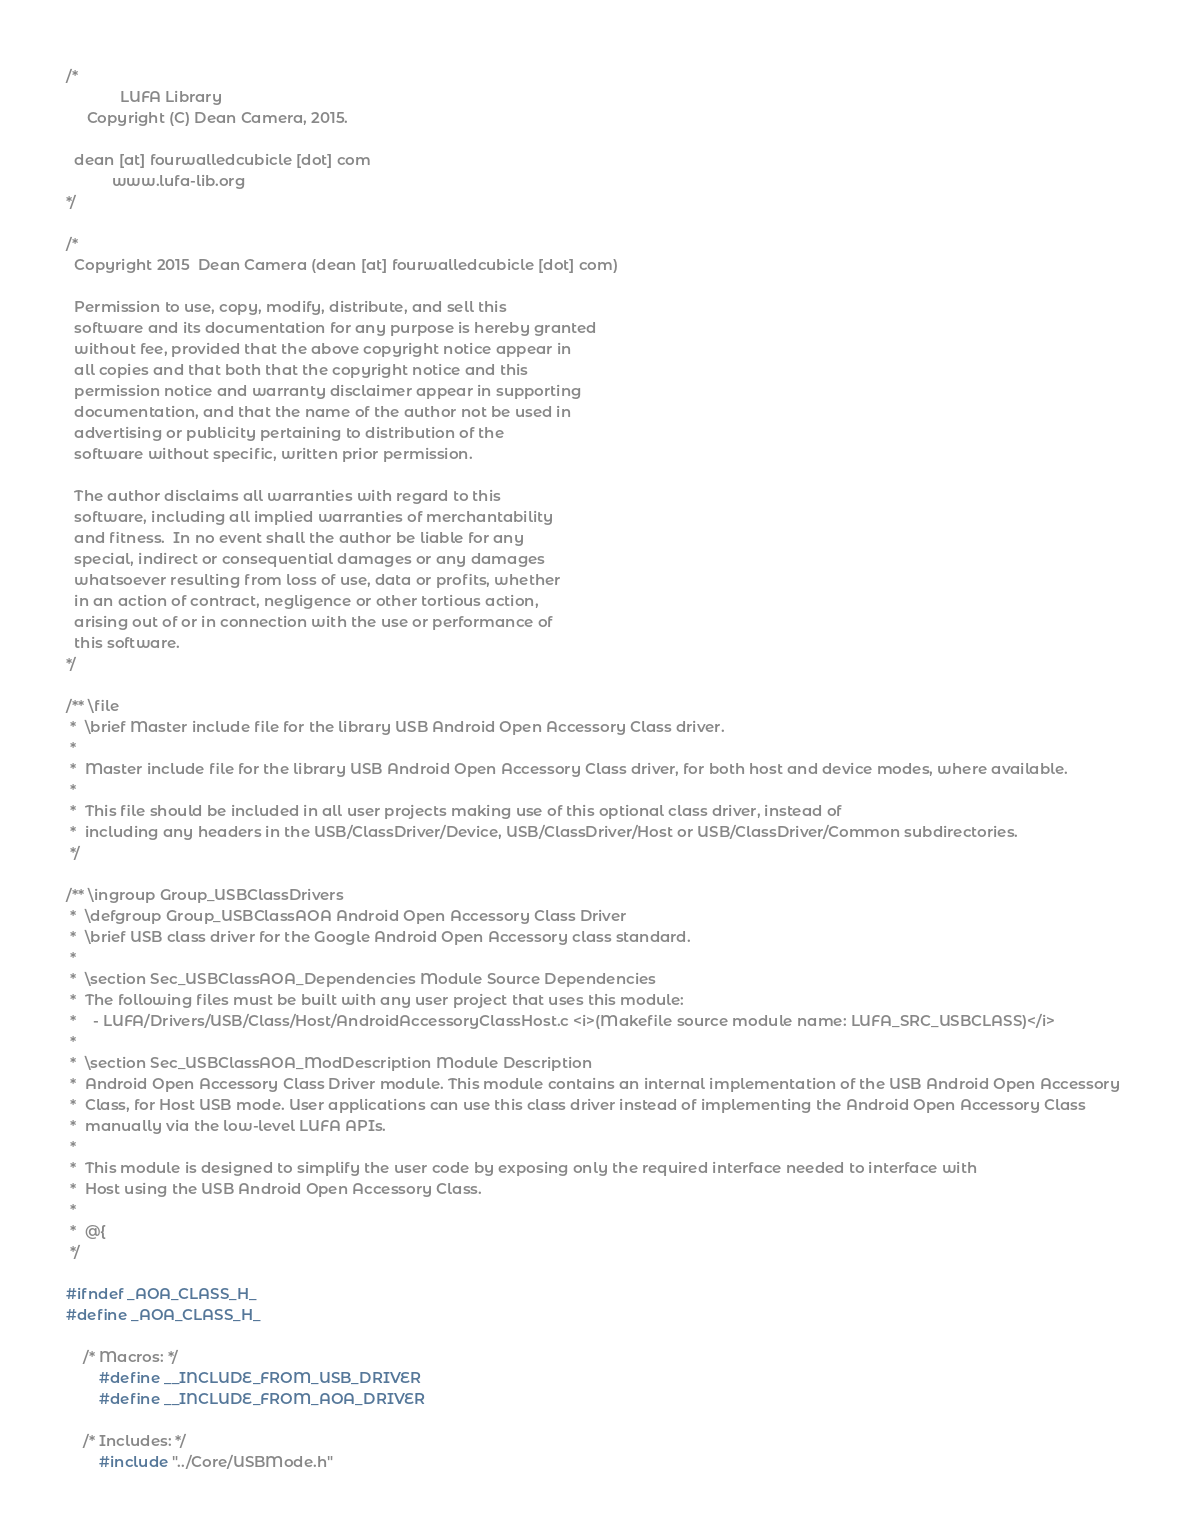<code> <loc_0><loc_0><loc_500><loc_500><_C_>/*
             LUFA Library
     Copyright (C) Dean Camera, 2015.

  dean [at] fourwalledcubicle [dot] com
           www.lufa-lib.org
*/

/*
  Copyright 2015  Dean Camera (dean [at] fourwalledcubicle [dot] com)

  Permission to use, copy, modify, distribute, and sell this
  software and its documentation for any purpose is hereby granted
  without fee, provided that the above copyright notice appear in
  all copies and that both that the copyright notice and this
  permission notice and warranty disclaimer appear in supporting
  documentation, and that the name of the author not be used in
  advertising or publicity pertaining to distribution of the
  software without specific, written prior permission.

  The author disclaims all warranties with regard to this
  software, including all implied warranties of merchantability
  and fitness.  In no event shall the author be liable for any
  special, indirect or consequential damages or any damages
  whatsoever resulting from loss of use, data or profits, whether
  in an action of contract, negligence or other tortious action,
  arising out of or in connection with the use or performance of
  this software.
*/

/** \file
 *  \brief Master include file for the library USB Android Open Accessory Class driver.
 *
 *  Master include file for the library USB Android Open Accessory Class driver, for both host and device modes, where available.
 *
 *  This file should be included in all user projects making use of this optional class driver, instead of
 *  including any headers in the USB/ClassDriver/Device, USB/ClassDriver/Host or USB/ClassDriver/Common subdirectories.
 */

/** \ingroup Group_USBClassDrivers
 *  \defgroup Group_USBClassAOA Android Open Accessory Class Driver
 *  \brief USB class driver for the Google Android Open Accessory class standard.
 *
 *  \section Sec_USBClassAOA_Dependencies Module Source Dependencies
 *  The following files must be built with any user project that uses this module:
 *    - LUFA/Drivers/USB/Class/Host/AndroidAccessoryClassHost.c <i>(Makefile source module name: LUFA_SRC_USBCLASS)</i>
 *
 *  \section Sec_USBClassAOA_ModDescription Module Description
 *  Android Open Accessory Class Driver module. This module contains an internal implementation of the USB Android Open Accessory
 *  Class, for Host USB mode. User applications can use this class driver instead of implementing the Android Open Accessory Class
 *  manually via the low-level LUFA APIs.
 *
 *  This module is designed to simplify the user code by exposing only the required interface needed to interface with
 *  Host using the USB Android Open Accessory Class.
 *
 *  @{
 */

#ifndef _AOA_CLASS_H_
#define _AOA_CLASS_H_

	/* Macros: */
		#define __INCLUDE_FROM_USB_DRIVER
		#define __INCLUDE_FROM_AOA_DRIVER

	/* Includes: */
		#include "../Core/USBMode.h"
</code> 